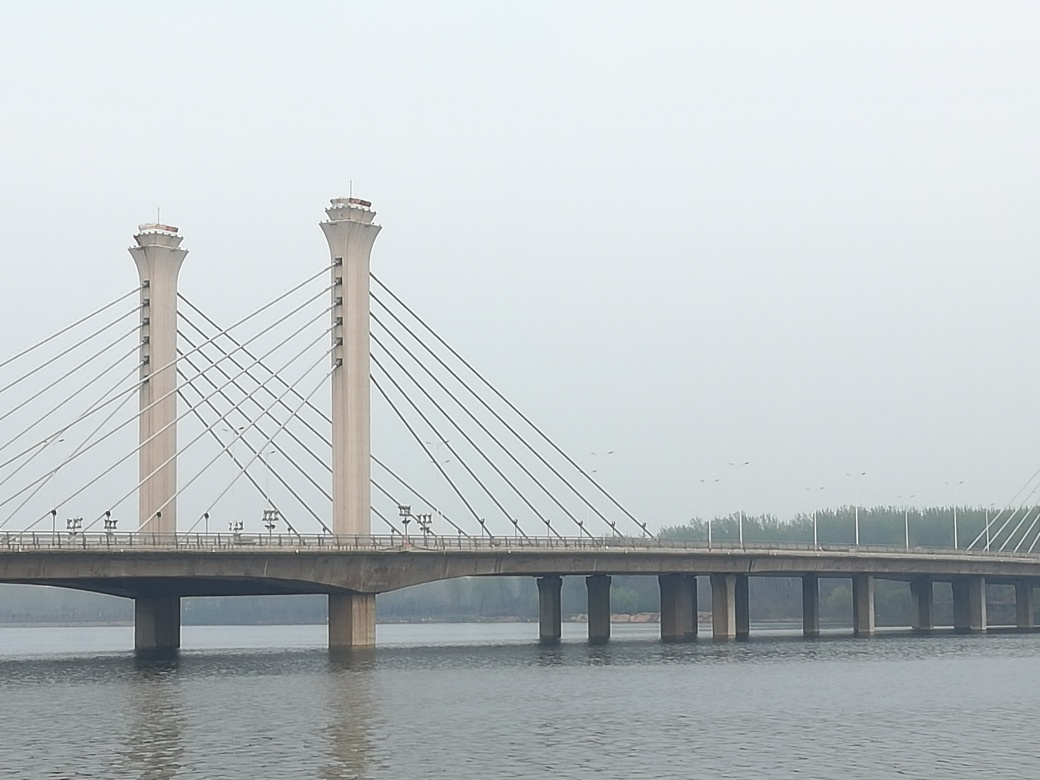What type of bridge is this and what might its location suggest about its design? This bridge appears to be a cable-stayed bridge, characterized by the cables running diagonally from the towers to support the bridge deck. Its robust design suggests that it's meant to span a considerable width of water, indicative of a large river or estuary, which requires a design that can withstand the forces of nature, such as strong winds or heavy traffic. Could you tell me more about the surroundings of the bridge? The bridge is situated in a flat and open landscape, with no immediate tall structures or mountains in sight. The openness of the surroundings, along with the haze implies that it may be located in an urban area dealing with air quality issues, or near industrial sites. Additionally, the lack of visible boats or ships suggests that this section of the waterway might not be heavily trafficked by maritime vessels. 